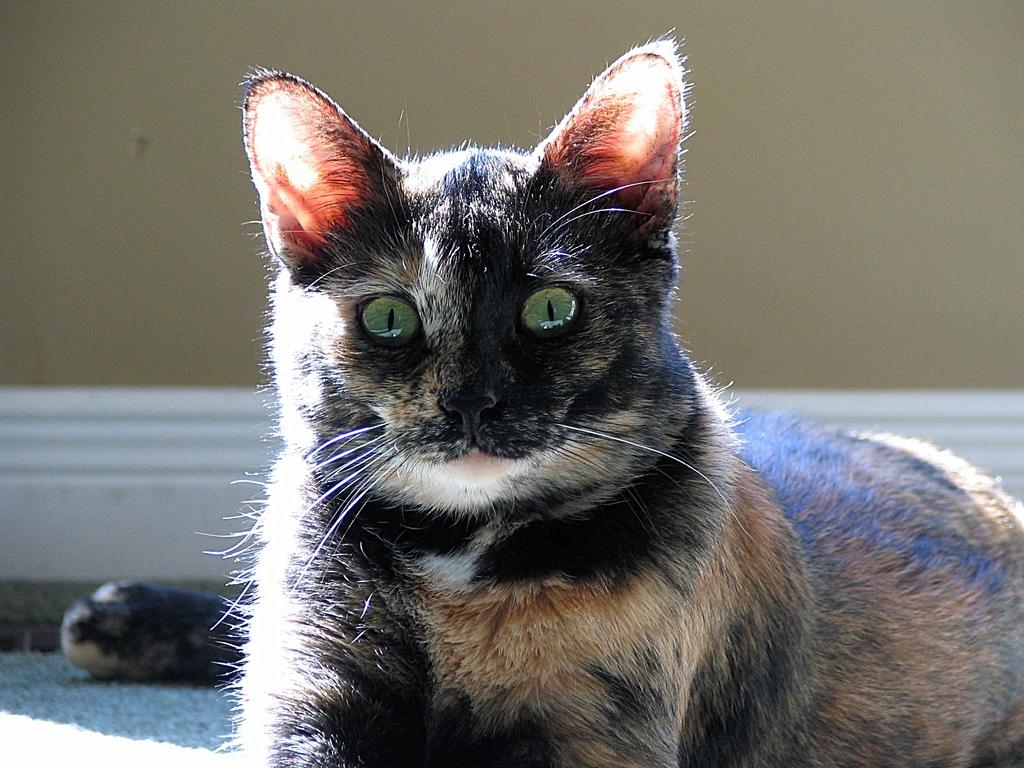What type of animal is in the image? There is a black cat in the image. Where is the cat located in the image? The cat is sitting on the floor. What can be seen in the background of the image? There appears to be a wall in the image. What color is the crayon that the cat is holding in the image? There is no crayon present in the image, and the cat is not holding anything. 